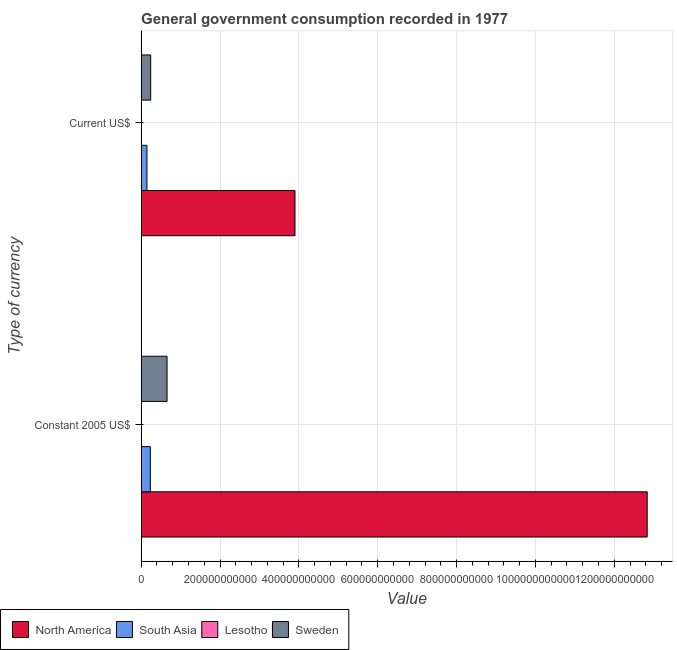How many different coloured bars are there?
Your answer should be very brief. 4. How many groups of bars are there?
Keep it short and to the point. 2. What is the label of the 2nd group of bars from the top?
Give a very brief answer. Constant 2005 US$. What is the value consumed in current us$ in North America?
Give a very brief answer. 3.90e+11. Across all countries, what is the maximum value consumed in current us$?
Keep it short and to the point. 3.90e+11. Across all countries, what is the minimum value consumed in constant 2005 us$?
Offer a very short reply. 1.28e+08. In which country was the value consumed in current us$ maximum?
Provide a short and direct response. North America. In which country was the value consumed in current us$ minimum?
Provide a succinct answer. Lesotho. What is the total value consumed in current us$ in the graph?
Offer a terse response. 4.29e+11. What is the difference between the value consumed in current us$ in South Asia and that in Lesotho?
Your answer should be very brief. 1.47e+1. What is the difference between the value consumed in current us$ in Lesotho and the value consumed in constant 2005 us$ in Sweden?
Your answer should be very brief. -6.57e+1. What is the average value consumed in current us$ per country?
Ensure brevity in your answer.  1.07e+11. What is the difference between the value consumed in constant 2005 us$ and value consumed in current us$ in Lesotho?
Keep it short and to the point. 1.03e+08. In how many countries, is the value consumed in current us$ greater than 440000000000 ?
Your response must be concise. 0. What is the ratio of the value consumed in current us$ in North America to that in South Asia?
Ensure brevity in your answer.  26.54. Is the value consumed in current us$ in South Asia less than that in Lesotho?
Offer a terse response. No. What does the 3rd bar from the bottom in Constant 2005 US$ represents?
Your response must be concise. Lesotho. How many countries are there in the graph?
Make the answer very short. 4. What is the difference between two consecutive major ticks on the X-axis?
Offer a terse response. 2.00e+11. Does the graph contain any zero values?
Provide a short and direct response. No. How are the legend labels stacked?
Offer a very short reply. Horizontal. What is the title of the graph?
Offer a very short reply. General government consumption recorded in 1977. Does "Malta" appear as one of the legend labels in the graph?
Your answer should be compact. No. What is the label or title of the X-axis?
Provide a succinct answer. Value. What is the label or title of the Y-axis?
Offer a terse response. Type of currency. What is the Value of North America in Constant 2005 US$?
Make the answer very short. 1.28e+12. What is the Value in South Asia in Constant 2005 US$?
Keep it short and to the point. 2.33e+1. What is the Value of Lesotho in Constant 2005 US$?
Make the answer very short. 1.28e+08. What is the Value in Sweden in Constant 2005 US$?
Your response must be concise. 6.57e+1. What is the Value of North America in Current US$?
Provide a succinct answer. 3.90e+11. What is the Value of South Asia in Current US$?
Give a very brief answer. 1.47e+1. What is the Value of Lesotho in Current US$?
Offer a very short reply. 2.53e+07. What is the Value in Sweden in Current US$?
Your response must be concise. 2.42e+1. Across all Type of currency, what is the maximum Value in North America?
Provide a succinct answer. 1.28e+12. Across all Type of currency, what is the maximum Value in South Asia?
Offer a terse response. 2.33e+1. Across all Type of currency, what is the maximum Value in Lesotho?
Ensure brevity in your answer.  1.28e+08. Across all Type of currency, what is the maximum Value of Sweden?
Provide a short and direct response. 6.57e+1. Across all Type of currency, what is the minimum Value in North America?
Make the answer very short. 3.90e+11. Across all Type of currency, what is the minimum Value in South Asia?
Offer a terse response. 1.47e+1. Across all Type of currency, what is the minimum Value of Lesotho?
Make the answer very short. 2.53e+07. Across all Type of currency, what is the minimum Value in Sweden?
Your response must be concise. 2.42e+1. What is the total Value in North America in the graph?
Your response must be concise. 1.67e+12. What is the total Value of South Asia in the graph?
Provide a succinct answer. 3.80e+1. What is the total Value in Lesotho in the graph?
Your answer should be compact. 1.54e+08. What is the total Value in Sweden in the graph?
Your response must be concise. 9.00e+1. What is the difference between the Value in North America in Constant 2005 US$ and that in Current US$?
Keep it short and to the point. 8.93e+11. What is the difference between the Value of South Asia in Constant 2005 US$ and that in Current US$?
Provide a succinct answer. 8.56e+09. What is the difference between the Value of Lesotho in Constant 2005 US$ and that in Current US$?
Offer a very short reply. 1.03e+08. What is the difference between the Value of Sweden in Constant 2005 US$ and that in Current US$?
Offer a very short reply. 4.15e+1. What is the difference between the Value in North America in Constant 2005 US$ and the Value in South Asia in Current US$?
Give a very brief answer. 1.27e+12. What is the difference between the Value of North America in Constant 2005 US$ and the Value of Lesotho in Current US$?
Keep it short and to the point. 1.28e+12. What is the difference between the Value of North America in Constant 2005 US$ and the Value of Sweden in Current US$?
Ensure brevity in your answer.  1.26e+12. What is the difference between the Value of South Asia in Constant 2005 US$ and the Value of Lesotho in Current US$?
Make the answer very short. 2.32e+1. What is the difference between the Value of South Asia in Constant 2005 US$ and the Value of Sweden in Current US$?
Offer a very short reply. -9.86e+08. What is the difference between the Value of Lesotho in Constant 2005 US$ and the Value of Sweden in Current US$?
Ensure brevity in your answer.  -2.41e+1. What is the average Value in North America per Type of currency?
Keep it short and to the point. 8.37e+11. What is the average Value of South Asia per Type of currency?
Provide a succinct answer. 1.90e+1. What is the average Value in Lesotho per Type of currency?
Make the answer very short. 7.68e+07. What is the average Value in Sweden per Type of currency?
Ensure brevity in your answer.  4.50e+1. What is the difference between the Value in North America and Value in South Asia in Constant 2005 US$?
Your answer should be very brief. 1.26e+12. What is the difference between the Value in North America and Value in Lesotho in Constant 2005 US$?
Offer a terse response. 1.28e+12. What is the difference between the Value in North America and Value in Sweden in Constant 2005 US$?
Your answer should be very brief. 1.22e+12. What is the difference between the Value of South Asia and Value of Lesotho in Constant 2005 US$?
Give a very brief answer. 2.31e+1. What is the difference between the Value in South Asia and Value in Sweden in Constant 2005 US$?
Make the answer very short. -4.25e+1. What is the difference between the Value in Lesotho and Value in Sweden in Constant 2005 US$?
Give a very brief answer. -6.56e+1. What is the difference between the Value in North America and Value in South Asia in Current US$?
Provide a succinct answer. 3.75e+11. What is the difference between the Value of North America and Value of Lesotho in Current US$?
Your answer should be compact. 3.90e+11. What is the difference between the Value in North America and Value in Sweden in Current US$?
Keep it short and to the point. 3.66e+11. What is the difference between the Value in South Asia and Value in Lesotho in Current US$?
Keep it short and to the point. 1.47e+1. What is the difference between the Value in South Asia and Value in Sweden in Current US$?
Your answer should be very brief. -9.55e+09. What is the difference between the Value of Lesotho and Value of Sweden in Current US$?
Make the answer very short. -2.42e+1. What is the ratio of the Value in North America in Constant 2005 US$ to that in Current US$?
Offer a terse response. 3.29. What is the ratio of the Value of South Asia in Constant 2005 US$ to that in Current US$?
Your answer should be compact. 1.58. What is the ratio of the Value of Lesotho in Constant 2005 US$ to that in Current US$?
Keep it short and to the point. 5.07. What is the ratio of the Value in Sweden in Constant 2005 US$ to that in Current US$?
Provide a short and direct response. 2.71. What is the difference between the highest and the second highest Value of North America?
Make the answer very short. 8.93e+11. What is the difference between the highest and the second highest Value of South Asia?
Provide a short and direct response. 8.56e+09. What is the difference between the highest and the second highest Value in Lesotho?
Your response must be concise. 1.03e+08. What is the difference between the highest and the second highest Value of Sweden?
Your answer should be compact. 4.15e+1. What is the difference between the highest and the lowest Value of North America?
Offer a very short reply. 8.93e+11. What is the difference between the highest and the lowest Value in South Asia?
Offer a terse response. 8.56e+09. What is the difference between the highest and the lowest Value in Lesotho?
Make the answer very short. 1.03e+08. What is the difference between the highest and the lowest Value of Sweden?
Offer a terse response. 4.15e+1. 